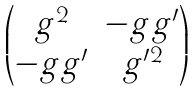<formula> <loc_0><loc_0><loc_500><loc_500>\begin{pmatrix} g ^ { 2 } & - g g ^ { \prime } \\ - g g ^ { \prime } & g ^ { \prime 2 } \\ \end{pmatrix}</formula> 